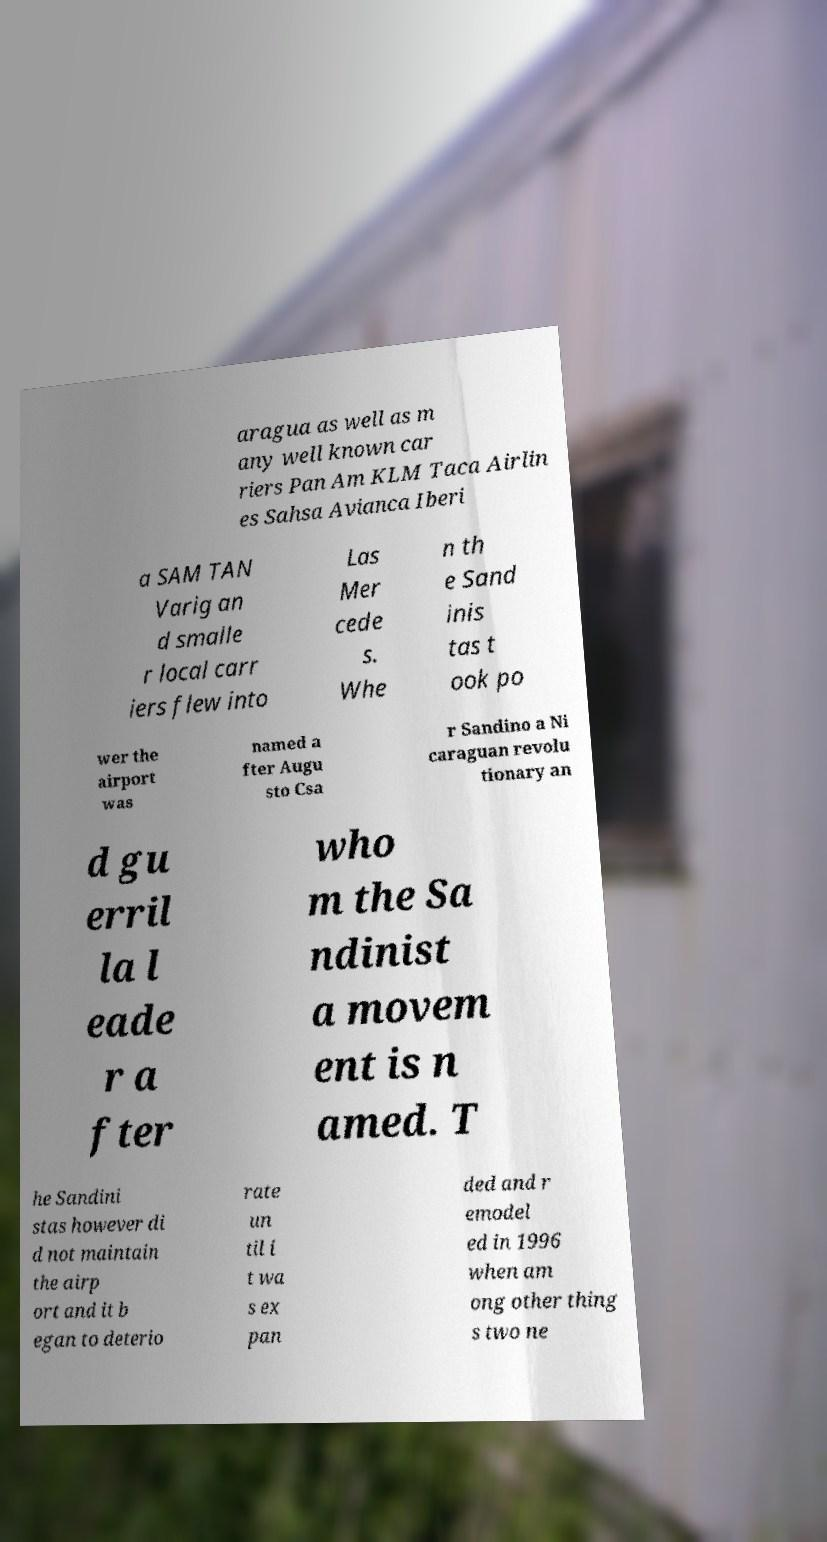What messages or text are displayed in this image? I need them in a readable, typed format. aragua as well as m any well known car riers Pan Am KLM Taca Airlin es Sahsa Avianca Iberi a SAM TAN Varig an d smalle r local carr iers flew into Las Mer cede s. Whe n th e Sand inis tas t ook po wer the airport was named a fter Augu sto Csa r Sandino a Ni caraguan revolu tionary an d gu erril la l eade r a fter who m the Sa ndinist a movem ent is n amed. T he Sandini stas however di d not maintain the airp ort and it b egan to deterio rate un til i t wa s ex pan ded and r emodel ed in 1996 when am ong other thing s two ne 